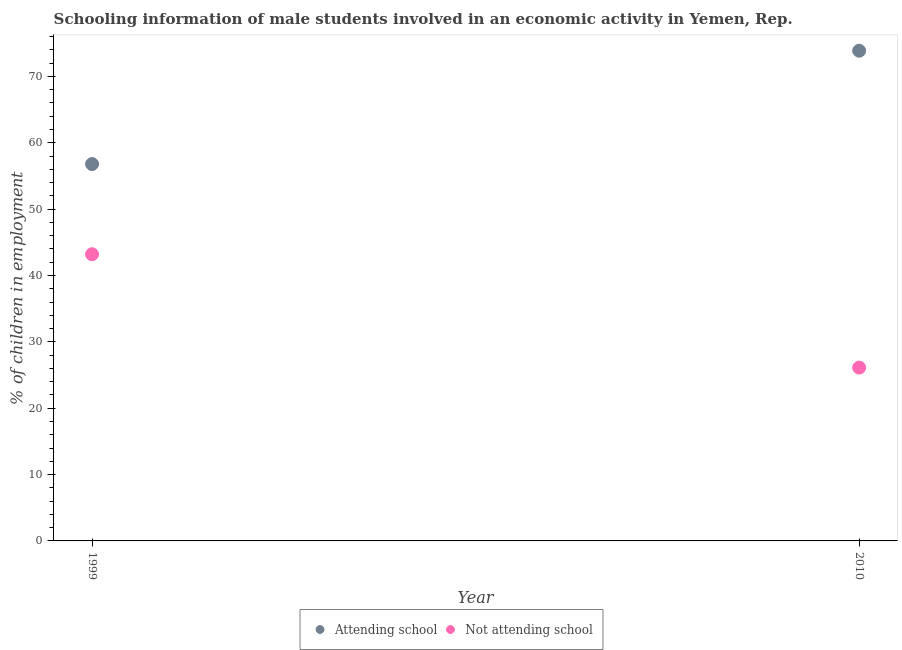What is the percentage of employed males who are not attending school in 2010?
Provide a short and direct response. 26.12. Across all years, what is the maximum percentage of employed males who are attending school?
Offer a very short reply. 73.88. Across all years, what is the minimum percentage of employed males who are not attending school?
Make the answer very short. 26.12. In which year was the percentage of employed males who are attending school minimum?
Make the answer very short. 1999. What is the total percentage of employed males who are attending school in the graph?
Provide a succinct answer. 130.67. What is the difference between the percentage of employed males who are not attending school in 1999 and that in 2010?
Your response must be concise. 17.08. What is the difference between the percentage of employed males who are attending school in 2010 and the percentage of employed males who are not attending school in 1999?
Your response must be concise. 30.67. What is the average percentage of employed males who are attending school per year?
Give a very brief answer. 65.34. In the year 2010, what is the difference between the percentage of employed males who are attending school and percentage of employed males who are not attending school?
Offer a terse response. 47.76. What is the ratio of the percentage of employed males who are not attending school in 1999 to that in 2010?
Your response must be concise. 1.65. Is the percentage of employed males who are attending school in 1999 less than that in 2010?
Offer a very short reply. Yes. Is the percentage of employed males who are not attending school strictly greater than the percentage of employed males who are attending school over the years?
Ensure brevity in your answer.  No. How many years are there in the graph?
Make the answer very short. 2. What is the difference between two consecutive major ticks on the Y-axis?
Give a very brief answer. 10. How are the legend labels stacked?
Provide a succinct answer. Horizontal. What is the title of the graph?
Provide a short and direct response. Schooling information of male students involved in an economic activity in Yemen, Rep. Does "UN agencies" appear as one of the legend labels in the graph?
Your answer should be very brief. No. What is the label or title of the Y-axis?
Make the answer very short. % of children in employment. What is the % of children in employment in Attending school in 1999?
Provide a succinct answer. 56.8. What is the % of children in employment of Not attending school in 1999?
Offer a very short reply. 43.2. What is the % of children in employment of Attending school in 2010?
Your answer should be very brief. 73.88. What is the % of children in employment of Not attending school in 2010?
Make the answer very short. 26.12. Across all years, what is the maximum % of children in employment of Attending school?
Give a very brief answer. 73.88. Across all years, what is the maximum % of children in employment of Not attending school?
Keep it short and to the point. 43.2. Across all years, what is the minimum % of children in employment in Attending school?
Make the answer very short. 56.8. Across all years, what is the minimum % of children in employment of Not attending school?
Your response must be concise. 26.12. What is the total % of children in employment in Attending school in the graph?
Keep it short and to the point. 130.67. What is the total % of children in employment of Not attending school in the graph?
Offer a terse response. 69.33. What is the difference between the % of children in employment in Attending school in 1999 and that in 2010?
Provide a short and direct response. -17.08. What is the difference between the % of children in employment of Not attending school in 1999 and that in 2010?
Provide a short and direct response. 17.08. What is the difference between the % of children in employment of Attending school in 1999 and the % of children in employment of Not attending school in 2010?
Give a very brief answer. 30.67. What is the average % of children in employment of Attending school per year?
Your answer should be compact. 65.34. What is the average % of children in employment of Not attending school per year?
Ensure brevity in your answer.  34.66. In the year 1999, what is the difference between the % of children in employment in Attending school and % of children in employment in Not attending school?
Keep it short and to the point. 13.59. In the year 2010, what is the difference between the % of children in employment of Attending school and % of children in employment of Not attending school?
Your response must be concise. 47.76. What is the ratio of the % of children in employment in Attending school in 1999 to that in 2010?
Provide a succinct answer. 0.77. What is the ratio of the % of children in employment in Not attending school in 1999 to that in 2010?
Your response must be concise. 1.65. What is the difference between the highest and the second highest % of children in employment in Attending school?
Keep it short and to the point. 17.08. What is the difference between the highest and the second highest % of children in employment of Not attending school?
Provide a succinct answer. 17.08. What is the difference between the highest and the lowest % of children in employment of Attending school?
Your answer should be very brief. 17.08. What is the difference between the highest and the lowest % of children in employment of Not attending school?
Provide a short and direct response. 17.08. 